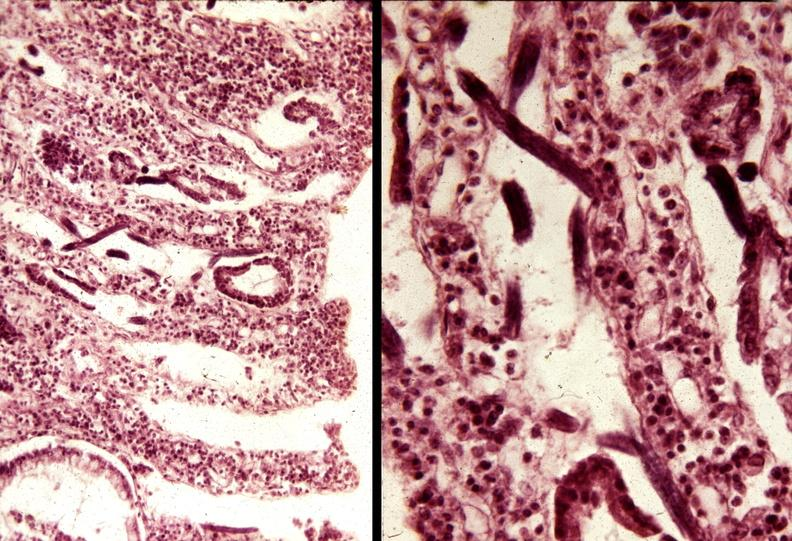s gastrointestinal present?
Answer the question using a single word or phrase. Yes 